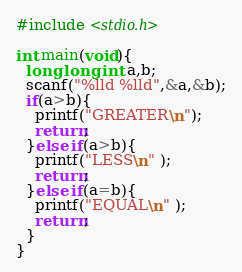<code> <loc_0><loc_0><loc_500><loc_500><_C_>#include <stdio.h>

int main(void){
  long long int a,b;
  scanf("%lld %lld",&a,&b);
  if(a>b){
    printf("GREATER\n");
    return;
  }else if(a>b){
    printf("LESS\n" );
    return;
  }else if(a=b){
    printf("EQUAL\n" );
    return;
  }
}
</code> 